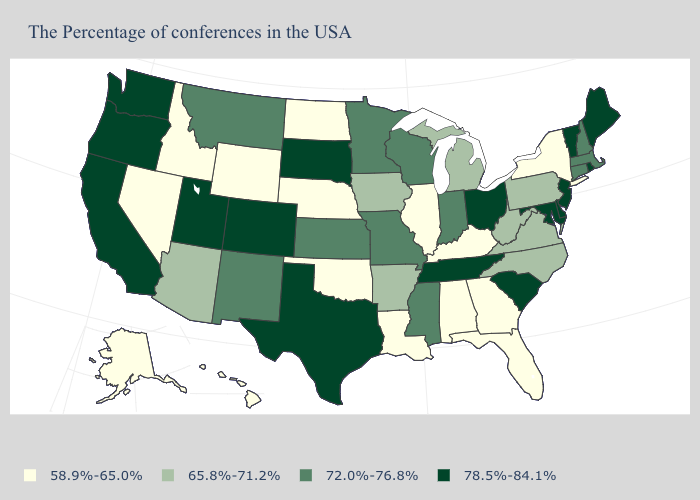What is the lowest value in the USA?
Quick response, please. 58.9%-65.0%. Name the states that have a value in the range 65.8%-71.2%?
Quick response, please. Pennsylvania, Virginia, North Carolina, West Virginia, Michigan, Arkansas, Iowa, Arizona. What is the lowest value in the USA?
Answer briefly. 58.9%-65.0%. What is the value of Maine?
Short answer required. 78.5%-84.1%. What is the highest value in states that border Nebraska?
Short answer required. 78.5%-84.1%. Among the states that border Michigan , does Ohio have the lowest value?
Write a very short answer. No. Among the states that border Pennsylvania , which have the lowest value?
Short answer required. New York. Which states have the lowest value in the South?
Give a very brief answer. Florida, Georgia, Kentucky, Alabama, Louisiana, Oklahoma. What is the value of Montana?
Be succinct. 72.0%-76.8%. What is the highest value in the USA?
Give a very brief answer. 78.5%-84.1%. Is the legend a continuous bar?
Keep it brief. No. Which states have the lowest value in the USA?
Keep it brief. New York, Florida, Georgia, Kentucky, Alabama, Illinois, Louisiana, Nebraska, Oklahoma, North Dakota, Wyoming, Idaho, Nevada, Alaska, Hawaii. Name the states that have a value in the range 72.0%-76.8%?
Concise answer only. Massachusetts, New Hampshire, Connecticut, Indiana, Wisconsin, Mississippi, Missouri, Minnesota, Kansas, New Mexico, Montana. What is the value of Mississippi?
Answer briefly. 72.0%-76.8%. 